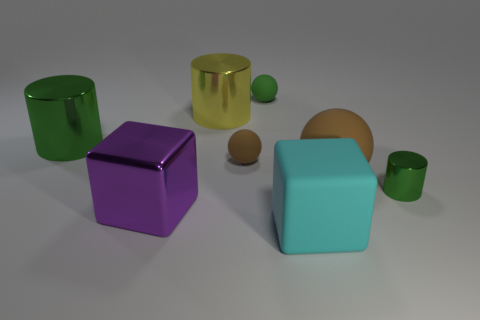Add 1 big cyan metallic things. How many objects exist? 9 Subtract all green matte balls. How many balls are left? 2 Subtract 2 brown balls. How many objects are left? 6 Subtract all cylinders. How many objects are left? 5 Subtract 2 cubes. How many cubes are left? 0 Subtract all gray cubes. Subtract all red balls. How many cubes are left? 2 Subtract all red spheres. How many purple blocks are left? 1 Subtract all brown spheres. Subtract all cyan blocks. How many objects are left? 5 Add 6 big cyan things. How many big cyan things are left? 7 Add 4 large yellow objects. How many large yellow objects exist? 5 